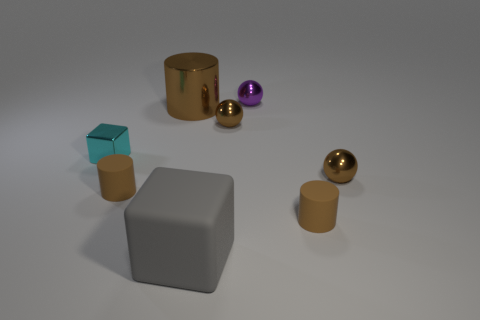Are there more tiny brown rubber things that are to the left of the big gray rubber block than tiny shiny cubes right of the large brown cylinder?
Provide a short and direct response. Yes. There is a tiny thing that is to the left of the small purple object and in front of the small metallic block; what material is it made of?
Offer a very short reply. Rubber. There is a tiny metal object that is the same shape as the big matte thing; what is its color?
Provide a succinct answer. Cyan. How big is the gray thing?
Your response must be concise. Large. The tiny metal thing that is to the left of the large thing behind the cyan metallic object is what color?
Your answer should be very brief. Cyan. How many objects are in front of the tiny purple sphere and behind the big gray cube?
Ensure brevity in your answer.  6. Is the number of large rubber objects greater than the number of gray shiny spheres?
Give a very brief answer. Yes. What is the material of the big cylinder?
Offer a terse response. Metal. There is a brown ball on the left side of the purple ball; what number of big gray blocks are in front of it?
Give a very brief answer. 1. Do the metal cylinder and the small shiny thing that is in front of the cyan thing have the same color?
Your response must be concise. Yes. 